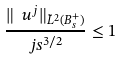Convert formula to latex. <formula><loc_0><loc_0><loc_500><loc_500>\frac { \| \ u ^ { j } \| _ { \tilde { L } ^ { 2 } ( B _ { s } ^ { + } ) } } { j s ^ { 3 / 2 } } \leq 1</formula> 